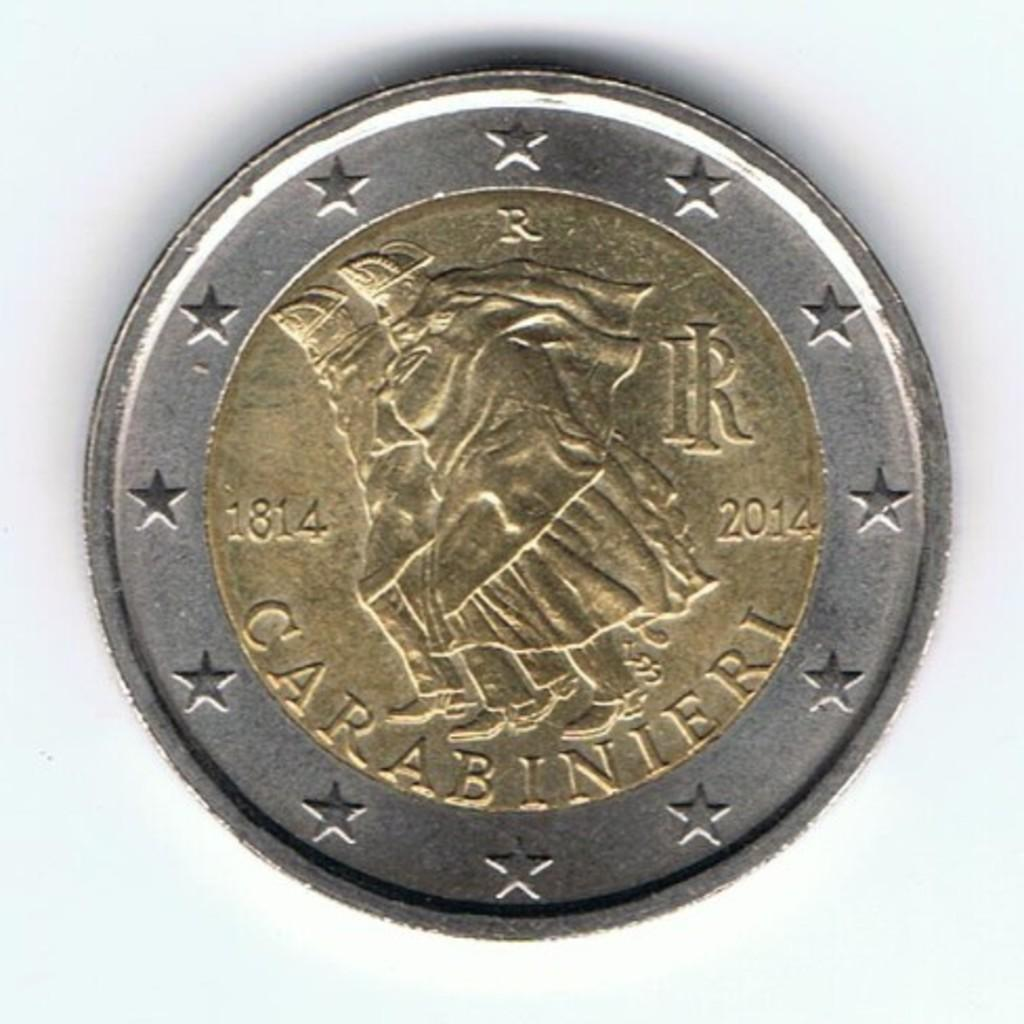<image>
Relay a brief, clear account of the picture shown. A coin has the years 1814 and 2014 shown on it. 